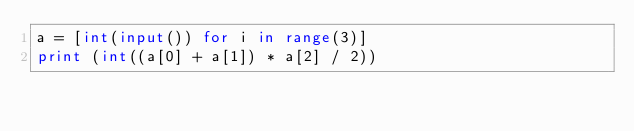Convert code to text. <code><loc_0><loc_0><loc_500><loc_500><_Python_>a = [int(input()) for i in range(3)]
print (int((a[0] + a[1]) * a[2] / 2))</code> 